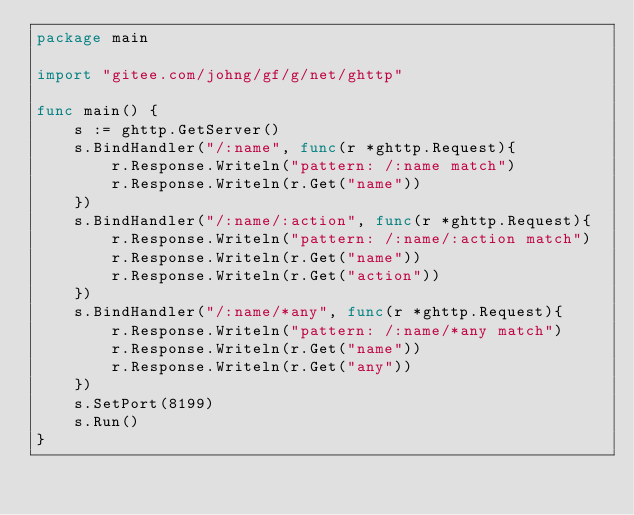<code> <loc_0><loc_0><loc_500><loc_500><_Go_>package main

import "gitee.com/johng/gf/g/net/ghttp"

func main() {
    s := ghttp.GetServer()
    s.BindHandler("/:name", func(r *ghttp.Request){
        r.Response.Writeln("pattern: /:name match")
        r.Response.Writeln(r.Get("name"))
    })
    s.BindHandler("/:name/:action", func(r *ghttp.Request){
        r.Response.Writeln("pattern: /:name/:action match")
        r.Response.Writeln(r.Get("name"))
        r.Response.Writeln(r.Get("action"))
    })
    s.BindHandler("/:name/*any", func(r *ghttp.Request){
        r.Response.Writeln("pattern: /:name/*any match")
        r.Response.Writeln(r.Get("name"))
        r.Response.Writeln(r.Get("any"))
    })
    s.SetPort(8199)
    s.Run()
}</code> 